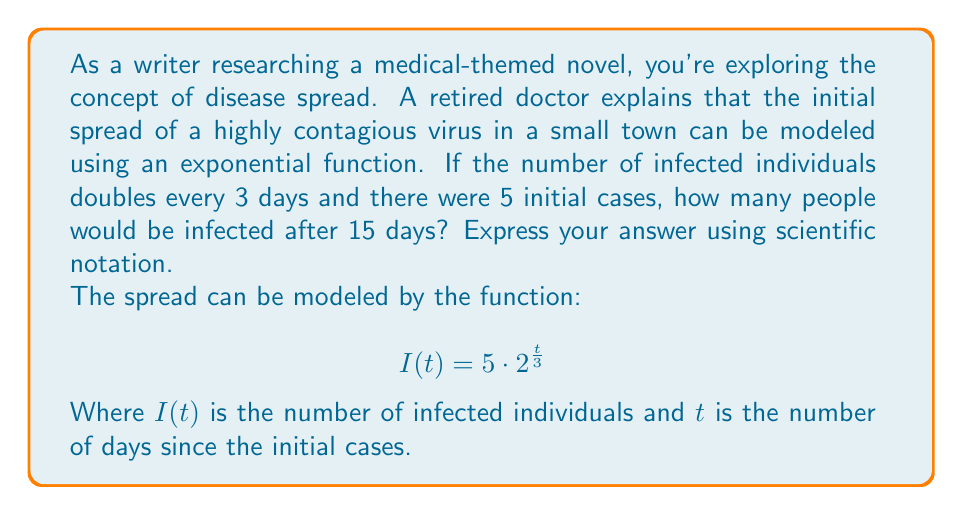Show me your answer to this math problem. Let's approach this step-by-step:

1) We're given the function $I(t) = 5 \cdot 2^{\frac{t}{3}}$, where:
   - $I(t)$ is the number of infected individuals
   - $t$ is the number of days
   - 5 is the initial number of cases
   - The exponent $\frac{t}{3}$ represents the number of doubling periods

2) We need to find $I(15)$, the number of infected individuals after 15 days.

3) Let's substitute $t = 15$ into the function:

   $I(15) = 5 \cdot 2^{\frac{15}{3}}$

4) Simplify the exponent:
   
   $I(15) = 5 \cdot 2^5$

5) Calculate $2^5$:
   
   $I(15) = 5 \cdot 32$

6) Multiply:
   
   $I(15) = 160$

7) Convert to scientific notation:
   
   $I(15) = 1.6 \times 10^2$

Therefore, after 15 days, 160 people (or $1.6 \times 10^2$ in scientific notation) would be infected.
Answer: $1.6 \times 10^2$ 